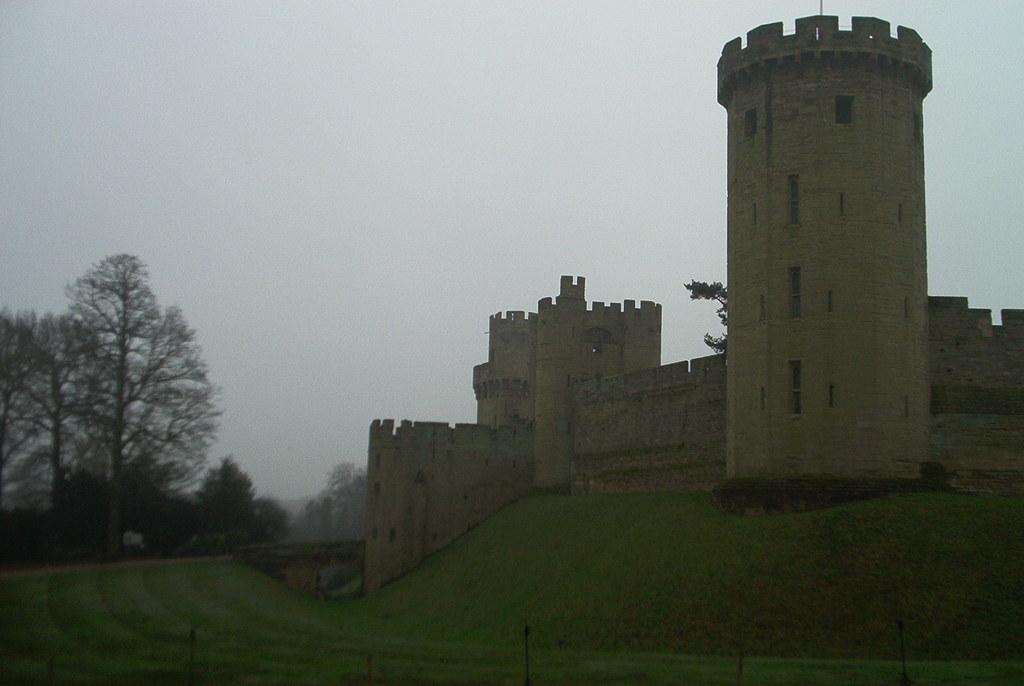What is the main structure in the image? There is a castle in the image. What type of vegetation is on the left side of the image? There are trees on the left side of the image. What is visible in the background of the image? The sky is visible in the background of the image. What type of dress is the castle wearing in the image? Castles do not wear dresses, as they are inanimate structures. 